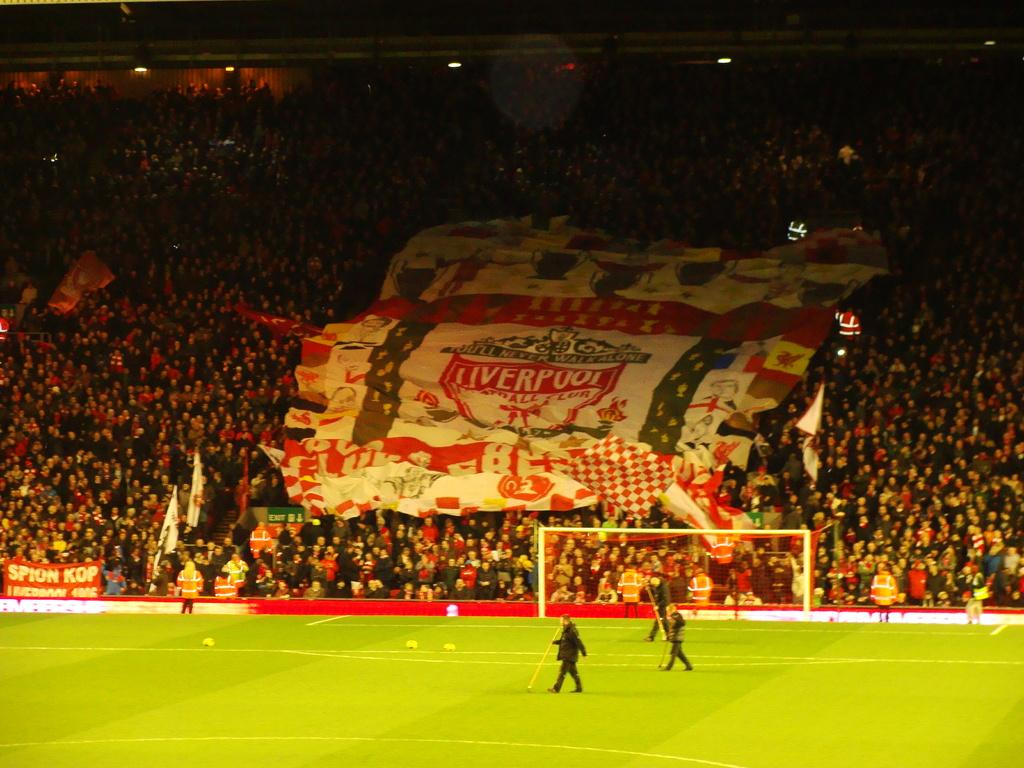<image>
Share a concise interpretation of the image provided. A packed stadium with people holding a large Liverpool banner. 